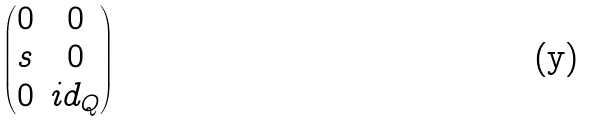Convert formula to latex. <formula><loc_0><loc_0><loc_500><loc_500>\begin{pmatrix} 0 & 0 \\ s & 0 \\ 0 & i d _ { Q } \end{pmatrix}</formula> 